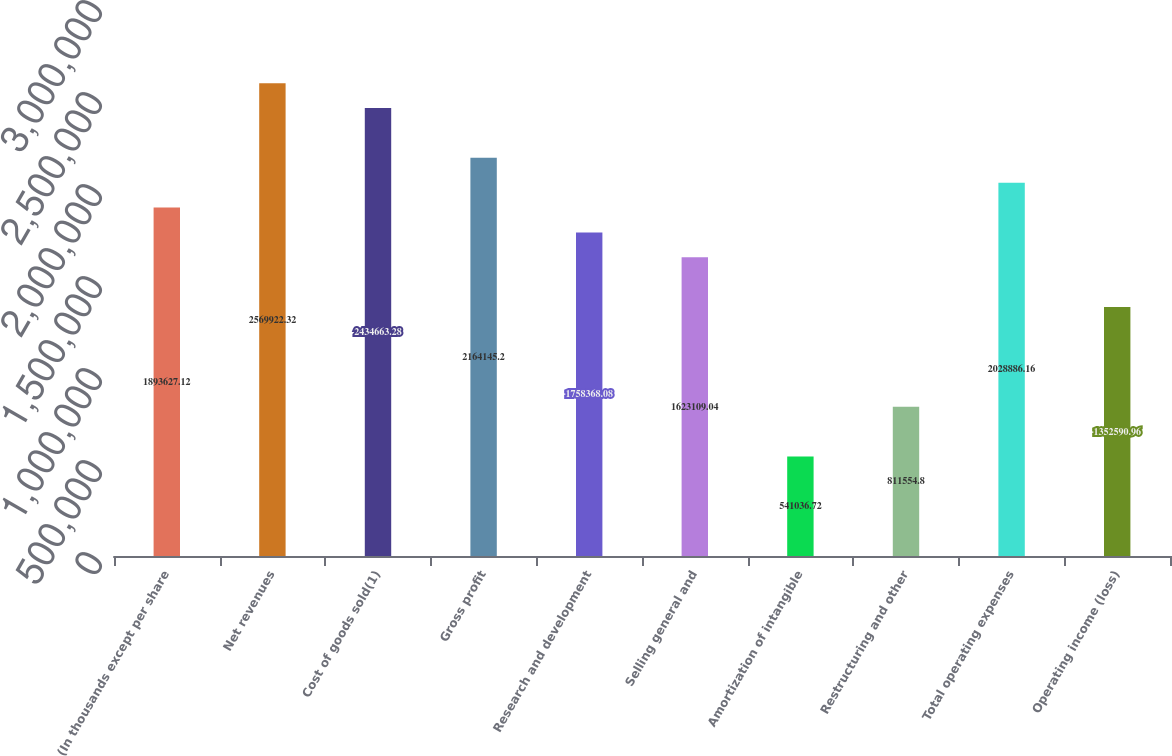Convert chart. <chart><loc_0><loc_0><loc_500><loc_500><bar_chart><fcel>(In thousands except per share<fcel>Net revenues<fcel>Cost of goods sold(1)<fcel>Gross profit<fcel>Research and development<fcel>Selling general and<fcel>Amortization of intangible<fcel>Restructuring and other<fcel>Total operating expenses<fcel>Operating income (loss)<nl><fcel>1.89363e+06<fcel>2.56992e+06<fcel>2.43466e+06<fcel>2.16415e+06<fcel>1.75837e+06<fcel>1.62311e+06<fcel>541037<fcel>811555<fcel>2.02889e+06<fcel>1.35259e+06<nl></chart> 